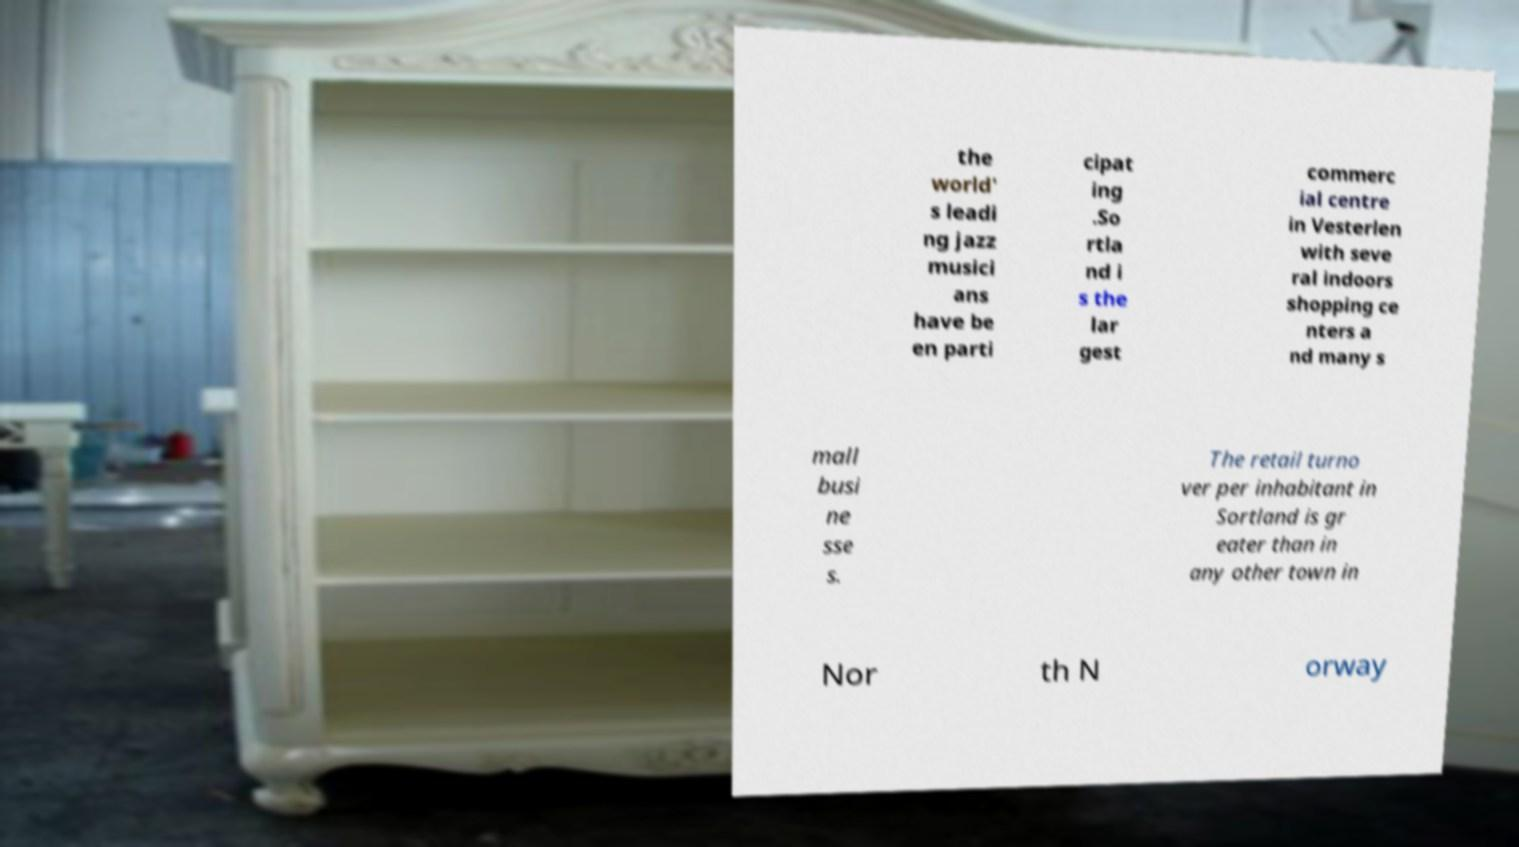Please read and relay the text visible in this image. What does it say? the world' s leadi ng jazz musici ans have be en parti cipat ing .So rtla nd i s the lar gest commerc ial centre in Vesterlen with seve ral indoors shopping ce nters a nd many s mall busi ne sse s. The retail turno ver per inhabitant in Sortland is gr eater than in any other town in Nor th N orway 